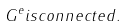<formula> <loc_0><loc_0><loc_500><loc_500>G ^ { e } i s c o n n e c t e d .</formula> 